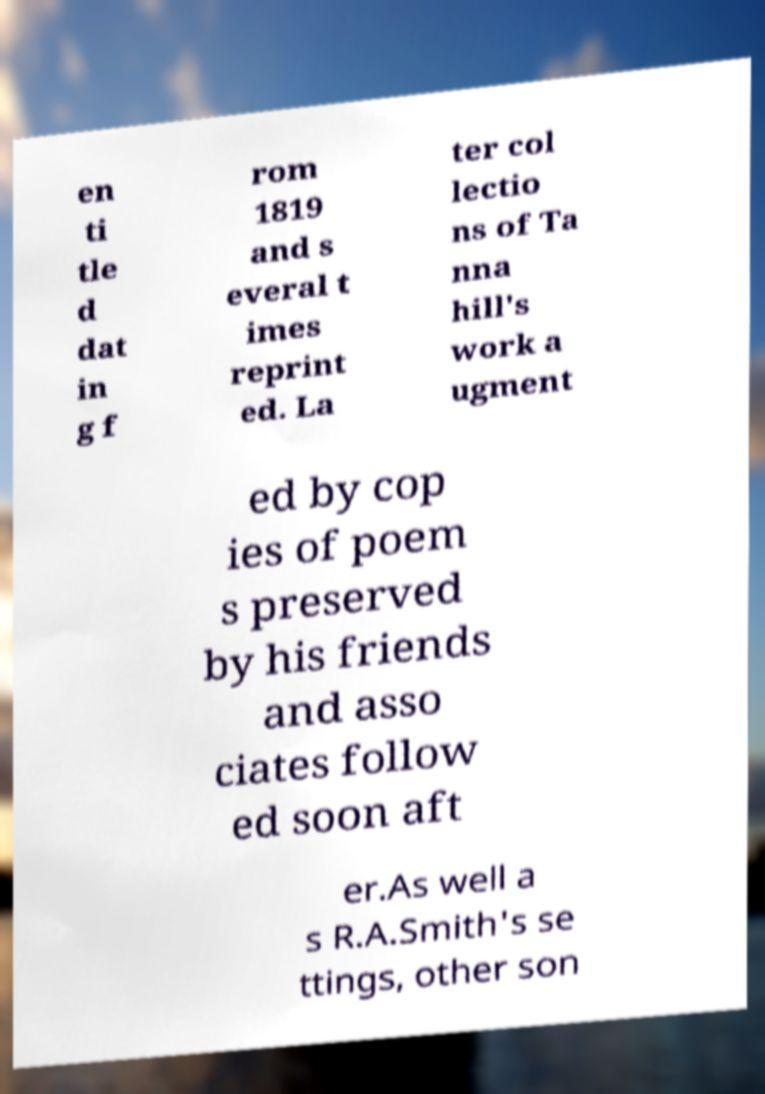Please identify and transcribe the text found in this image. en ti tle d dat in g f rom 1819 and s everal t imes reprint ed. La ter col lectio ns of Ta nna hill's work a ugment ed by cop ies of poem s preserved by his friends and asso ciates follow ed soon aft er.As well a s R.A.Smith's se ttings, other son 